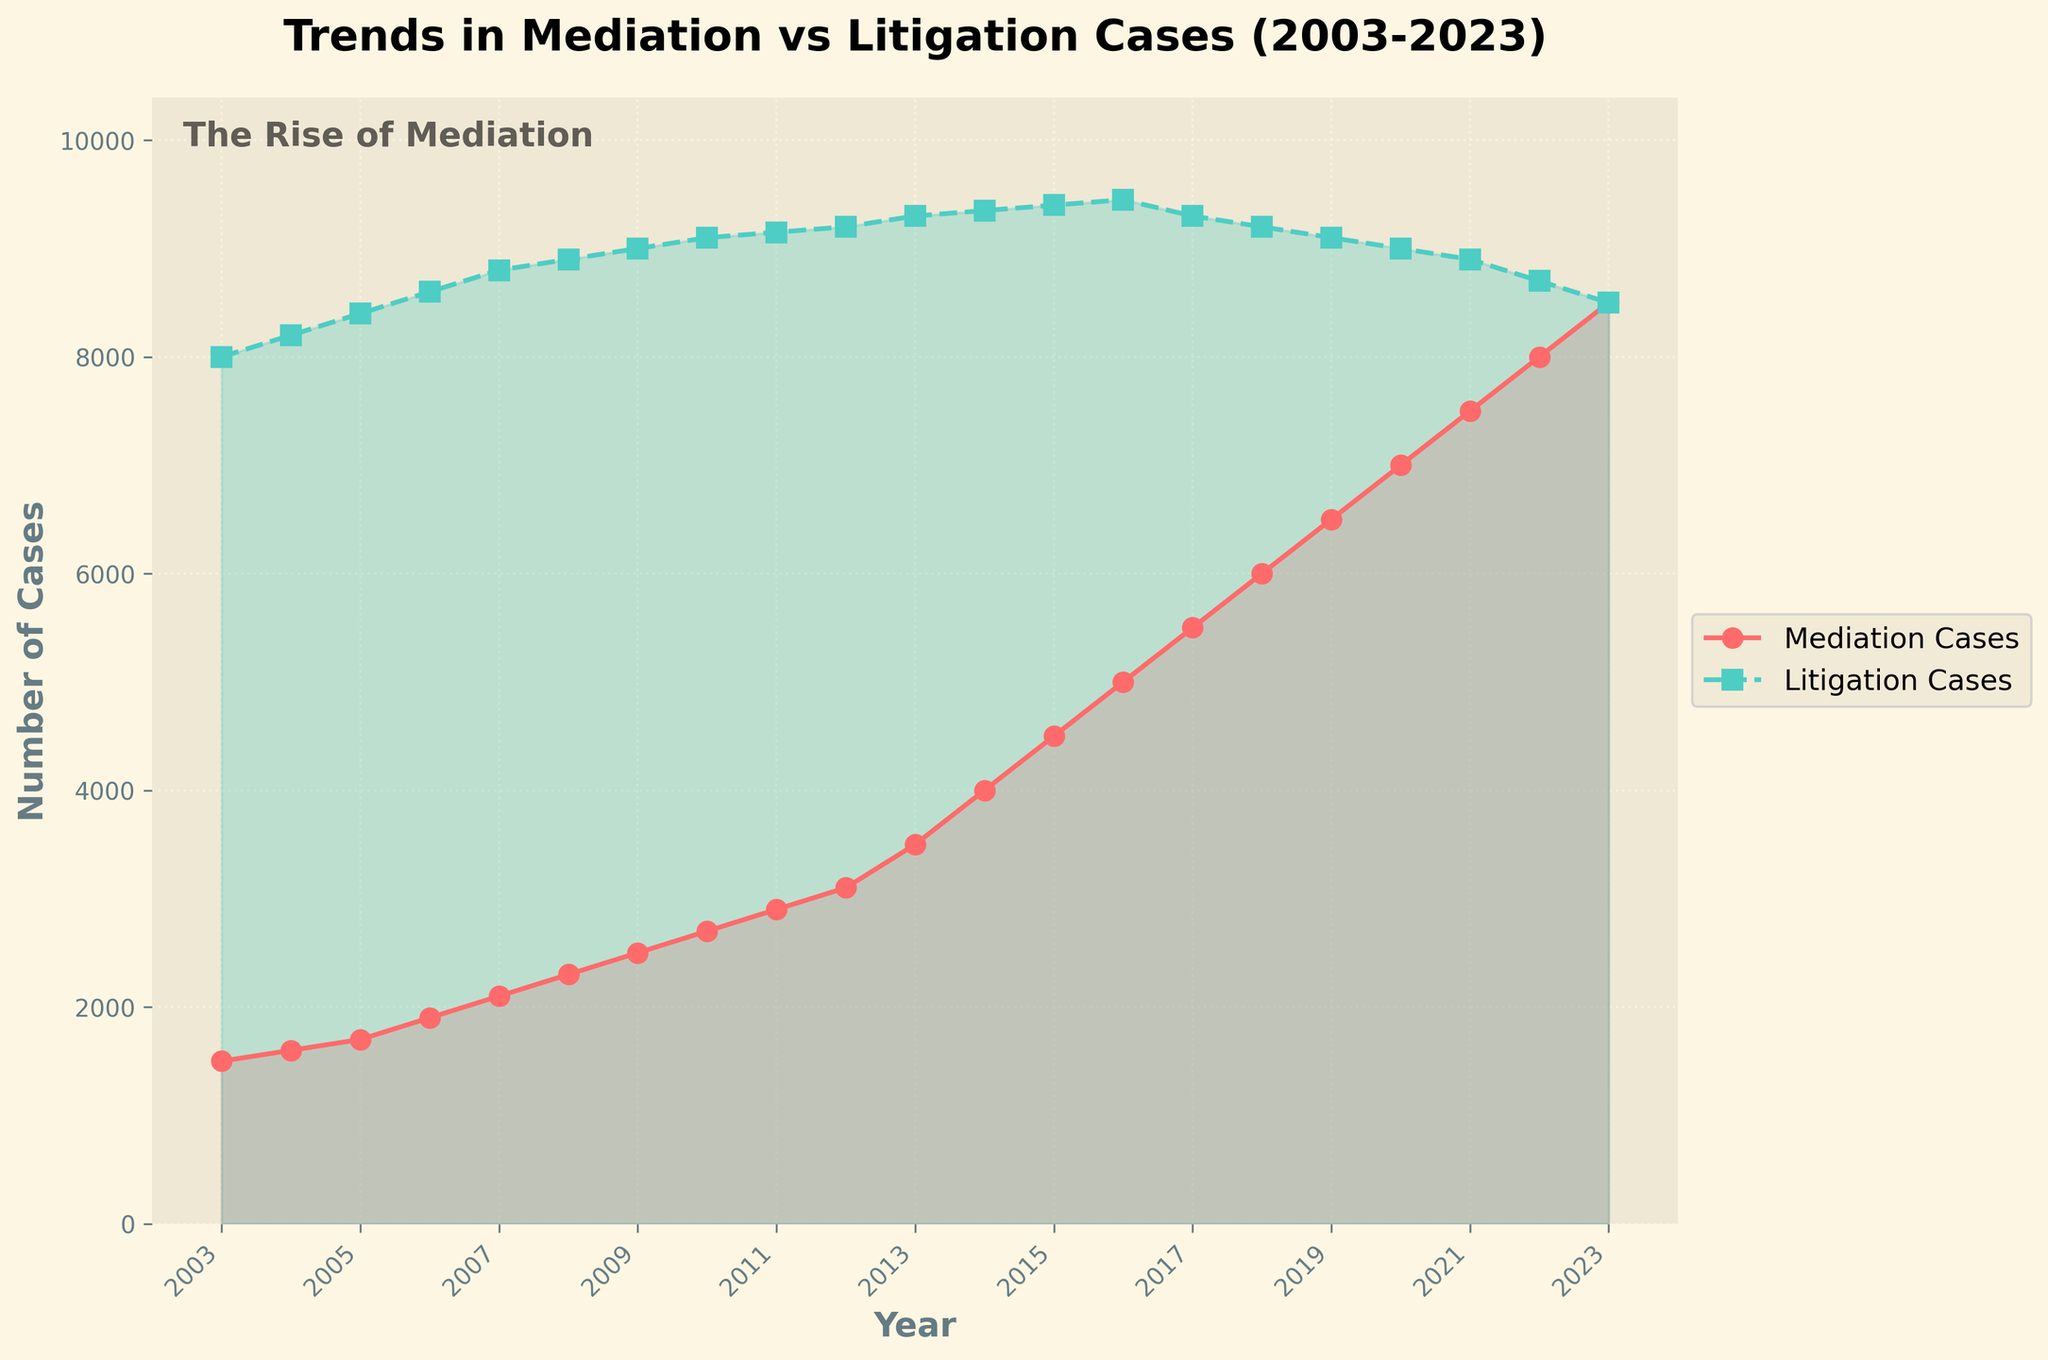What does the title of the figure indicate? The title of the figure is "Trends in Mediation vs Litigation Cases (2003-2023)", which indicates that the figure shows the trends in the number of mediation cases compared to litigation cases filed over the years from 2003 to 2023.
Answer: Trends in Mediation vs Litigation Cases (2003-2023) Which line represents mediation cases and which one represents litigation cases? The line representing mediation cases is the solid line with circular markers, and it is colored red. The line representing litigation cases is the dashed line with square markers, and it is colored green.
Answer: Solid red line for mediation cases, dashed green line for litigation cases How do the number of mediation cases change from 2003 to 2023? The number of mediation cases increases steadily from 1500 in 2003 to 8500 in 2023. This indicates a consistent rise over the 20-year period.
Answer: Increases steadily from 1500 to 8500 By how much did the number of litigation cases decrease from 2016 to 2023? In 2016, the number of litigation cases was 9450, and it decreased to 8500 in 2023. The difference is 9450 - 8500, which is 950 cases.
Answer: Decreased by 950 cases What is the trend in the number of litigation cases from 2003 to 2023? The number of litigation cases increased slightly from 8000 in 2003 to a peak of 9450 in 2016, but then it decreased steadily back to 8500 in 2023. Overall, there is an initial rise followed by a decline.
Answer: Initial rise followed by a decline Was there any year where the number of mediation cases and litigation cases were equal or very close? In 2023, the number of mediation cases (8500) is equal to the number of litigation cases (8500). This is the only year where both numbers are exactly the same.
Answer: Yes, in 2023 What was the largest yearly increase in the number of mediation cases? The largest yearly increase in mediation cases occurred from 2012 to 2013, where the number of mediation cases increased from 3100 to 3500, an increase of 400 cases.
Answer: Increase of 400 cases, from 2012 to 2013 Between which years did the litigation cases reach their peak, and what was the number of cases at the peak? The litigation cases reached their peak between 2015 and 2016 with 9450 cases in 2016.
Answer: Between 2015 and 2016, with 9450 cases in 2016 How does the growth in mediation cases compare to the growth in litigation cases over the entire period? The growth in mediation cases shows a consistent upward trend, sharply rising after 2012. In contrast, litigation cases showed a slight upward trend until 2016, after which they declined. Mediation cases grew more steadily and intensely than litigation cases over the period.
Answer: Mediation cases grew more steadily and intensely If both trends continue, what can be inferred about the future comparison of mediation and litigation cases? If both trends continue, mediation cases will likely outnumber litigation cases even more significantly in the future, given the steady increase in mediation cases and the decline in litigation cases.
Answer: Mediation cases will outnumber litigation cases more significantly 